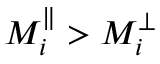<formula> <loc_0><loc_0><loc_500><loc_500>M _ { i } ^ { \| } > M _ { i } ^ { \perp }</formula> 